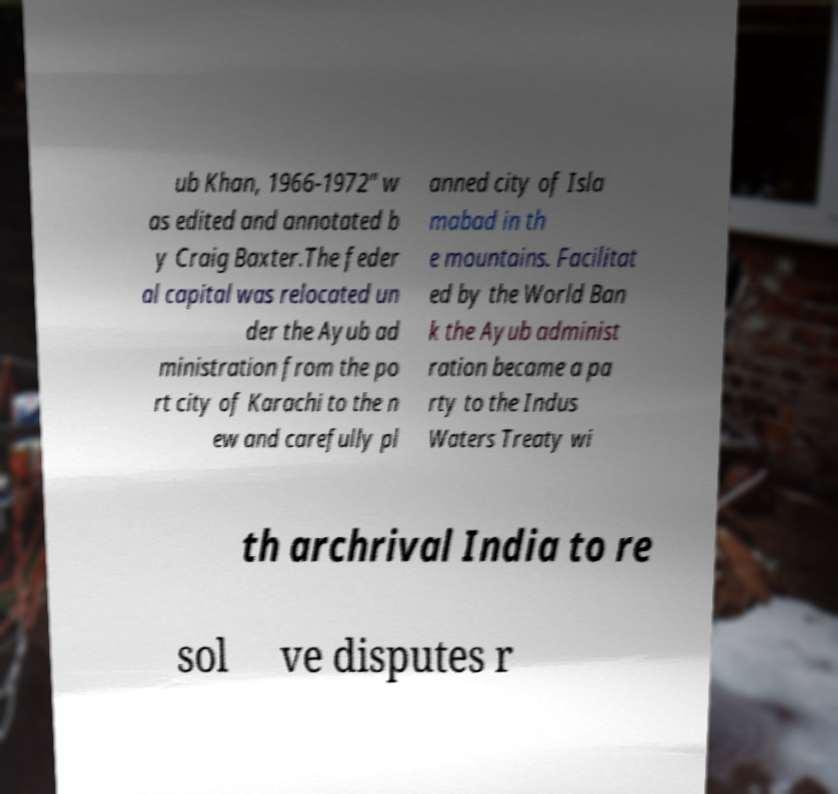Can you read and provide the text displayed in the image?This photo seems to have some interesting text. Can you extract and type it out for me? ub Khan, 1966-1972" w as edited and annotated b y Craig Baxter.The feder al capital was relocated un der the Ayub ad ministration from the po rt city of Karachi to the n ew and carefully pl anned city of Isla mabad in th e mountains. Facilitat ed by the World Ban k the Ayub administ ration became a pa rty to the Indus Waters Treaty wi th archrival India to re sol ve disputes r 